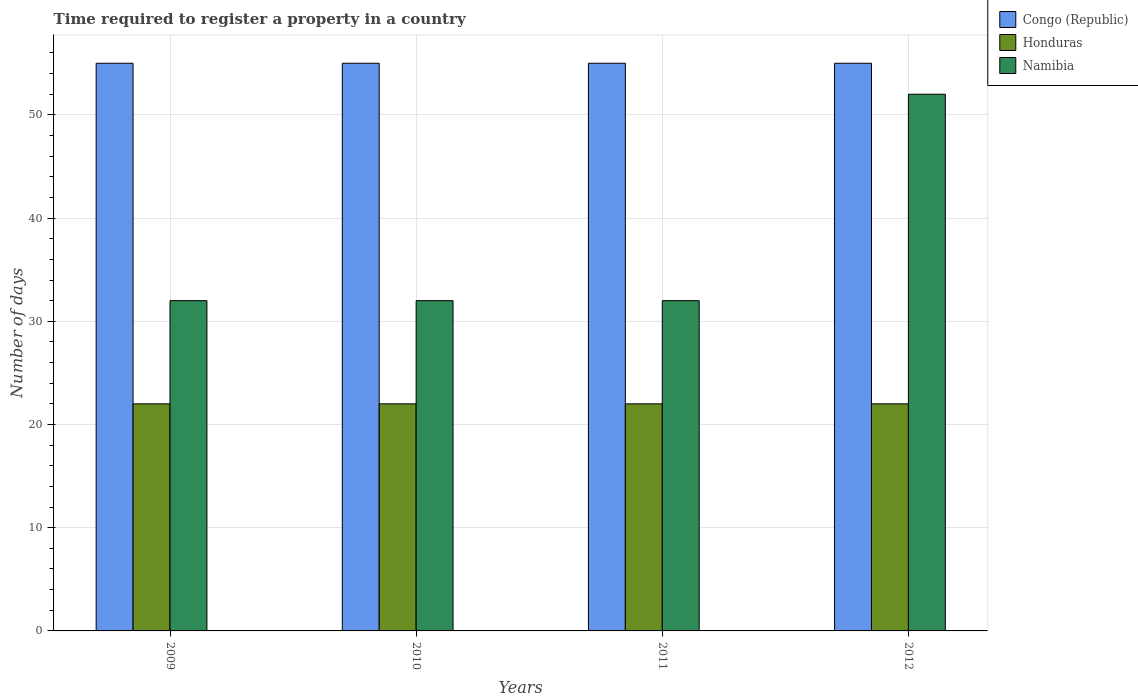How many groups of bars are there?
Give a very brief answer. 4. Are the number of bars per tick equal to the number of legend labels?
Your response must be concise. Yes. Are the number of bars on each tick of the X-axis equal?
Your answer should be very brief. Yes. What is the label of the 3rd group of bars from the left?
Your response must be concise. 2011. In how many cases, is the number of bars for a given year not equal to the number of legend labels?
Offer a terse response. 0. What is the number of days required to register a property in Namibia in 2010?
Your answer should be compact. 32. Across all years, what is the maximum number of days required to register a property in Honduras?
Keep it short and to the point. 22. Across all years, what is the minimum number of days required to register a property in Congo (Republic)?
Offer a very short reply. 55. In which year was the number of days required to register a property in Honduras minimum?
Your answer should be very brief. 2009. What is the total number of days required to register a property in Congo (Republic) in the graph?
Offer a very short reply. 220. What is the difference between the number of days required to register a property in Namibia in 2010 and that in 2012?
Provide a succinct answer. -20. What is the difference between the number of days required to register a property in Honduras in 2011 and the number of days required to register a property in Namibia in 2010?
Offer a terse response. -10. What is the average number of days required to register a property in Namibia per year?
Provide a short and direct response. 37. In the year 2009, what is the difference between the number of days required to register a property in Honduras and number of days required to register a property in Namibia?
Provide a succinct answer. -10. What is the ratio of the number of days required to register a property in Namibia in 2011 to that in 2012?
Provide a succinct answer. 0.62. Is the difference between the number of days required to register a property in Honduras in 2009 and 2012 greater than the difference between the number of days required to register a property in Namibia in 2009 and 2012?
Offer a very short reply. Yes. What is the difference between the highest and the lowest number of days required to register a property in Namibia?
Keep it short and to the point. 20. Is the sum of the number of days required to register a property in Honduras in 2010 and 2012 greater than the maximum number of days required to register a property in Congo (Republic) across all years?
Your answer should be compact. No. What does the 2nd bar from the left in 2011 represents?
Provide a short and direct response. Honduras. What does the 2nd bar from the right in 2011 represents?
Provide a short and direct response. Honduras. Is it the case that in every year, the sum of the number of days required to register a property in Congo (Republic) and number of days required to register a property in Honduras is greater than the number of days required to register a property in Namibia?
Make the answer very short. Yes. How many years are there in the graph?
Offer a terse response. 4. What is the difference between two consecutive major ticks on the Y-axis?
Give a very brief answer. 10. Are the values on the major ticks of Y-axis written in scientific E-notation?
Make the answer very short. No. What is the title of the graph?
Make the answer very short. Time required to register a property in a country. What is the label or title of the X-axis?
Your response must be concise. Years. What is the label or title of the Y-axis?
Make the answer very short. Number of days. What is the Number of days of Honduras in 2009?
Your answer should be compact. 22. What is the Number of days of Honduras in 2011?
Your answer should be compact. 22. What is the Number of days in Namibia in 2011?
Give a very brief answer. 32. What is the Number of days in Congo (Republic) in 2012?
Your answer should be very brief. 55. What is the Number of days of Honduras in 2012?
Your response must be concise. 22. What is the Number of days in Namibia in 2012?
Offer a terse response. 52. Across all years, what is the maximum Number of days in Congo (Republic)?
Your answer should be very brief. 55. Across all years, what is the maximum Number of days of Honduras?
Your answer should be compact. 22. Across all years, what is the minimum Number of days in Honduras?
Your answer should be compact. 22. Across all years, what is the minimum Number of days in Namibia?
Offer a terse response. 32. What is the total Number of days of Congo (Republic) in the graph?
Give a very brief answer. 220. What is the total Number of days of Honduras in the graph?
Offer a very short reply. 88. What is the total Number of days of Namibia in the graph?
Provide a succinct answer. 148. What is the difference between the Number of days in Honduras in 2009 and that in 2011?
Keep it short and to the point. 0. What is the difference between the Number of days of Namibia in 2009 and that in 2011?
Your answer should be compact. 0. What is the difference between the Number of days of Congo (Republic) in 2009 and that in 2012?
Your response must be concise. 0. What is the difference between the Number of days of Honduras in 2010 and that in 2012?
Offer a very short reply. 0. What is the difference between the Number of days of Namibia in 2011 and that in 2012?
Your answer should be compact. -20. What is the difference between the Number of days of Honduras in 2009 and the Number of days of Namibia in 2010?
Keep it short and to the point. -10. What is the difference between the Number of days in Congo (Republic) in 2009 and the Number of days in Honduras in 2011?
Offer a very short reply. 33. What is the difference between the Number of days of Honduras in 2009 and the Number of days of Namibia in 2011?
Your answer should be very brief. -10. What is the difference between the Number of days in Congo (Republic) in 2009 and the Number of days in Namibia in 2012?
Keep it short and to the point. 3. What is the difference between the Number of days in Honduras in 2009 and the Number of days in Namibia in 2012?
Make the answer very short. -30. What is the difference between the Number of days in Congo (Republic) in 2010 and the Number of days in Namibia in 2011?
Provide a short and direct response. 23. What is the difference between the Number of days in Honduras in 2010 and the Number of days in Namibia in 2011?
Provide a short and direct response. -10. What is the difference between the Number of days of Congo (Republic) in 2010 and the Number of days of Namibia in 2012?
Make the answer very short. 3. What is the difference between the Number of days of Honduras in 2010 and the Number of days of Namibia in 2012?
Keep it short and to the point. -30. What is the difference between the Number of days in Congo (Republic) in 2011 and the Number of days in Honduras in 2012?
Ensure brevity in your answer.  33. What is the difference between the Number of days of Honduras in 2011 and the Number of days of Namibia in 2012?
Make the answer very short. -30. What is the average Number of days in Congo (Republic) per year?
Keep it short and to the point. 55. What is the average Number of days of Honduras per year?
Offer a terse response. 22. In the year 2009, what is the difference between the Number of days in Congo (Republic) and Number of days in Namibia?
Provide a succinct answer. 23. In the year 2009, what is the difference between the Number of days of Honduras and Number of days of Namibia?
Offer a terse response. -10. In the year 2010, what is the difference between the Number of days of Congo (Republic) and Number of days of Honduras?
Your answer should be very brief. 33. In the year 2010, what is the difference between the Number of days in Honduras and Number of days in Namibia?
Offer a terse response. -10. In the year 2012, what is the difference between the Number of days of Congo (Republic) and Number of days of Namibia?
Keep it short and to the point. 3. In the year 2012, what is the difference between the Number of days of Honduras and Number of days of Namibia?
Your answer should be compact. -30. What is the ratio of the Number of days of Honduras in 2009 to that in 2010?
Give a very brief answer. 1. What is the ratio of the Number of days of Congo (Republic) in 2009 to that in 2011?
Keep it short and to the point. 1. What is the ratio of the Number of days of Honduras in 2009 to that in 2012?
Provide a succinct answer. 1. What is the ratio of the Number of days of Namibia in 2009 to that in 2012?
Offer a very short reply. 0.62. What is the ratio of the Number of days of Congo (Republic) in 2010 to that in 2012?
Your answer should be very brief. 1. What is the ratio of the Number of days of Namibia in 2010 to that in 2012?
Provide a short and direct response. 0.62. What is the ratio of the Number of days of Congo (Republic) in 2011 to that in 2012?
Your response must be concise. 1. What is the ratio of the Number of days of Honduras in 2011 to that in 2012?
Ensure brevity in your answer.  1. What is the ratio of the Number of days in Namibia in 2011 to that in 2012?
Your answer should be very brief. 0.62. What is the difference between the highest and the second highest Number of days in Congo (Republic)?
Give a very brief answer. 0. What is the difference between the highest and the lowest Number of days in Congo (Republic)?
Ensure brevity in your answer.  0. 